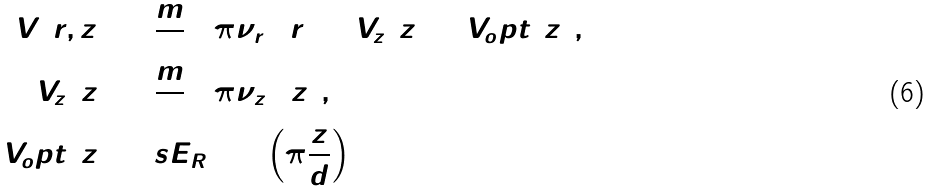Convert formula to latex. <formula><loc_0><loc_0><loc_500><loc_500>V ( r , z ) & = \frac { m } { 2 } ( 2 \pi \nu _ { r } ) ^ { 2 } r ^ { 2 } + V _ { z } ( z ) + V _ { o } p t ( z ) , \\ V _ { z } ( z ) & = \frac { m } { 2 } ( 2 \pi \nu _ { z } ) ^ { 2 } z ^ { 2 } , \\ V _ { o } p t ( z ) & = s E _ { R } \sin ^ { 2 } \left ( \pi \frac { z } { d } \right )</formula> 